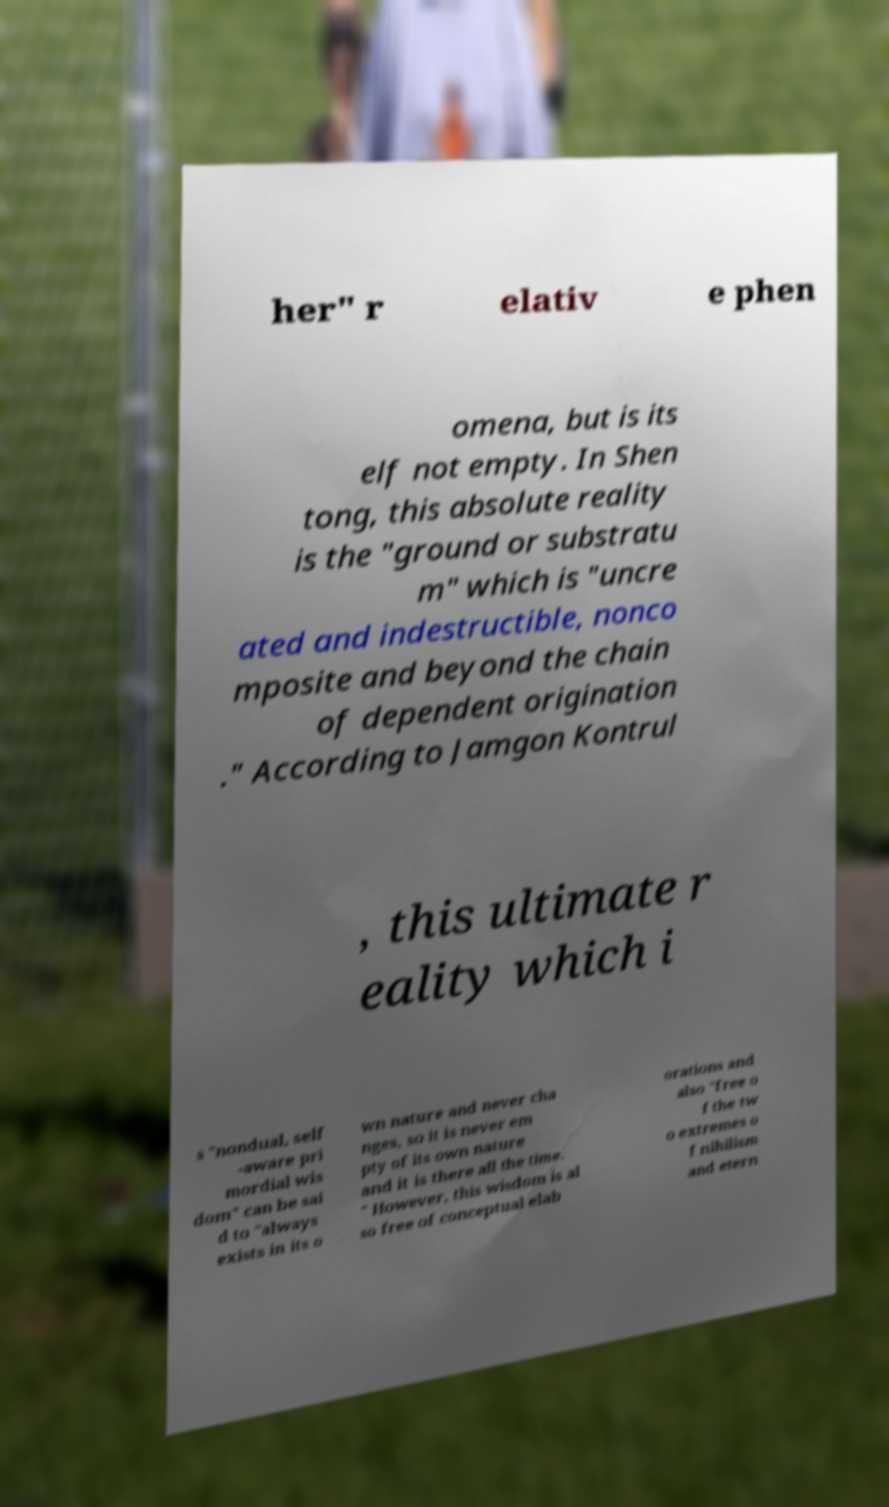Please identify and transcribe the text found in this image. her" r elativ e phen omena, but is its elf not empty. In Shen tong, this absolute reality is the "ground or substratu m" which is "uncre ated and indestructible, nonco mposite and beyond the chain of dependent origination ." According to Jamgon Kontrul , this ultimate r eality which i s "nondual, self -aware pri mordial wis dom" can be sai d to "always exists in its o wn nature and never cha nges, so it is never em pty of its own nature and it is there all the time. " However, this wisdom is al so free of conceptual elab orations and also "free o f the tw o extremes o f nihilism and etern 